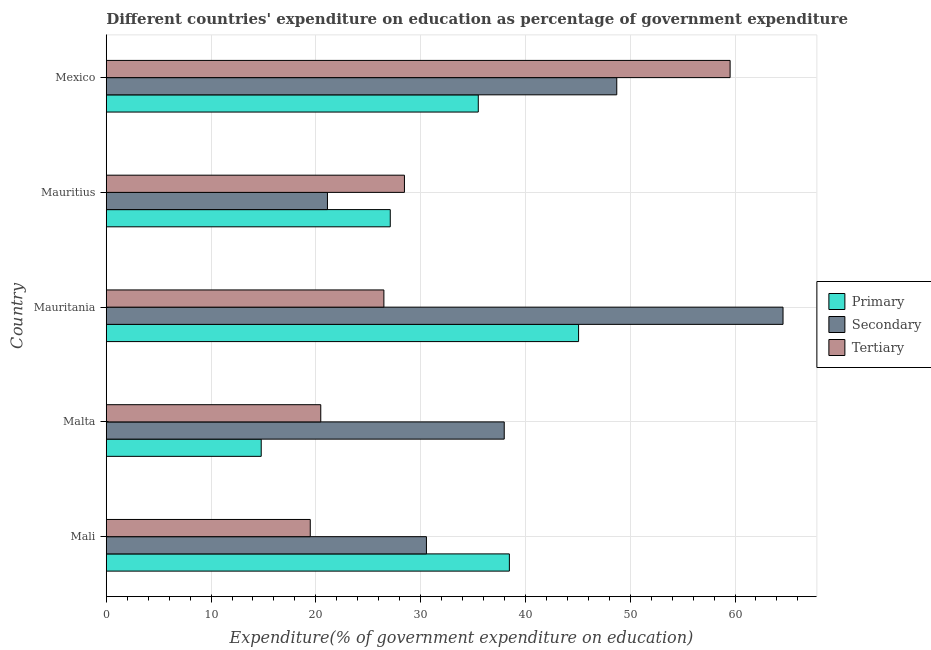How many different coloured bars are there?
Provide a short and direct response. 3. How many groups of bars are there?
Give a very brief answer. 5. Are the number of bars on each tick of the Y-axis equal?
Provide a succinct answer. Yes. How many bars are there on the 1st tick from the top?
Offer a terse response. 3. What is the label of the 4th group of bars from the top?
Give a very brief answer. Malta. In how many cases, is the number of bars for a given country not equal to the number of legend labels?
Your response must be concise. 0. What is the expenditure on tertiary education in Mauritania?
Ensure brevity in your answer.  26.49. Across all countries, what is the maximum expenditure on primary education?
Make the answer very short. 45.07. Across all countries, what is the minimum expenditure on secondary education?
Your answer should be compact. 21.11. In which country was the expenditure on primary education maximum?
Your response must be concise. Mauritania. In which country was the expenditure on primary education minimum?
Provide a succinct answer. Malta. What is the total expenditure on tertiary education in the graph?
Your response must be concise. 154.42. What is the difference between the expenditure on tertiary education in Mali and that in Malta?
Offer a terse response. -1. What is the difference between the expenditure on tertiary education in Mauritius and the expenditure on primary education in Mauritania?
Offer a very short reply. -16.62. What is the average expenditure on tertiary education per country?
Your response must be concise. 30.88. What is the difference between the expenditure on secondary education and expenditure on primary education in Mauritania?
Offer a very short reply. 19.51. What is the ratio of the expenditure on tertiary education in Mali to that in Mexico?
Your answer should be compact. 0.33. Is the difference between the expenditure on secondary education in Mauritania and Mauritius greater than the difference between the expenditure on primary education in Mauritania and Mauritius?
Offer a terse response. Yes. What is the difference between the highest and the second highest expenditure on primary education?
Offer a very short reply. 6.61. What is the difference between the highest and the lowest expenditure on secondary education?
Offer a terse response. 43.47. In how many countries, is the expenditure on secondary education greater than the average expenditure on secondary education taken over all countries?
Ensure brevity in your answer.  2. What does the 2nd bar from the top in Mali represents?
Your answer should be very brief. Secondary. What does the 1st bar from the bottom in Malta represents?
Ensure brevity in your answer.  Primary. Is it the case that in every country, the sum of the expenditure on primary education and expenditure on secondary education is greater than the expenditure on tertiary education?
Make the answer very short. Yes. Are all the bars in the graph horizontal?
Keep it short and to the point. Yes. How many countries are there in the graph?
Provide a succinct answer. 5. What is the difference between two consecutive major ticks on the X-axis?
Give a very brief answer. 10. Where does the legend appear in the graph?
Your answer should be compact. Center right. What is the title of the graph?
Make the answer very short. Different countries' expenditure on education as percentage of government expenditure. Does "Financial account" appear as one of the legend labels in the graph?
Provide a succinct answer. No. What is the label or title of the X-axis?
Your answer should be compact. Expenditure(% of government expenditure on education). What is the label or title of the Y-axis?
Make the answer very short. Country. What is the Expenditure(% of government expenditure on education) in Primary in Mali?
Make the answer very short. 38.47. What is the Expenditure(% of government expenditure on education) in Secondary in Mali?
Your answer should be compact. 30.55. What is the Expenditure(% of government expenditure on education) in Tertiary in Mali?
Your answer should be very brief. 19.47. What is the Expenditure(% of government expenditure on education) in Primary in Malta?
Ensure brevity in your answer.  14.79. What is the Expenditure(% of government expenditure on education) of Secondary in Malta?
Provide a short and direct response. 37.98. What is the Expenditure(% of government expenditure on education) of Tertiary in Malta?
Ensure brevity in your answer.  20.47. What is the Expenditure(% of government expenditure on education) in Primary in Mauritania?
Your response must be concise. 45.07. What is the Expenditure(% of government expenditure on education) in Secondary in Mauritania?
Your response must be concise. 64.58. What is the Expenditure(% of government expenditure on education) in Tertiary in Mauritania?
Provide a succinct answer. 26.49. What is the Expenditure(% of government expenditure on education) of Primary in Mauritius?
Offer a very short reply. 27.1. What is the Expenditure(% of government expenditure on education) of Secondary in Mauritius?
Provide a succinct answer. 21.11. What is the Expenditure(% of government expenditure on education) of Tertiary in Mauritius?
Give a very brief answer. 28.45. What is the Expenditure(% of government expenditure on education) of Primary in Mexico?
Keep it short and to the point. 35.5. What is the Expenditure(% of government expenditure on education) of Secondary in Mexico?
Give a very brief answer. 48.72. What is the Expenditure(% of government expenditure on education) of Tertiary in Mexico?
Give a very brief answer. 59.53. Across all countries, what is the maximum Expenditure(% of government expenditure on education) in Primary?
Your answer should be very brief. 45.07. Across all countries, what is the maximum Expenditure(% of government expenditure on education) in Secondary?
Your response must be concise. 64.58. Across all countries, what is the maximum Expenditure(% of government expenditure on education) of Tertiary?
Provide a succinct answer. 59.53. Across all countries, what is the minimum Expenditure(% of government expenditure on education) in Primary?
Provide a short and direct response. 14.79. Across all countries, what is the minimum Expenditure(% of government expenditure on education) of Secondary?
Offer a terse response. 21.11. Across all countries, what is the minimum Expenditure(% of government expenditure on education) of Tertiary?
Give a very brief answer. 19.47. What is the total Expenditure(% of government expenditure on education) in Primary in the graph?
Provide a short and direct response. 160.94. What is the total Expenditure(% of government expenditure on education) of Secondary in the graph?
Make the answer very short. 202.94. What is the total Expenditure(% of government expenditure on education) of Tertiary in the graph?
Offer a terse response. 154.42. What is the difference between the Expenditure(% of government expenditure on education) in Primary in Mali and that in Malta?
Give a very brief answer. 23.68. What is the difference between the Expenditure(% of government expenditure on education) of Secondary in Mali and that in Malta?
Keep it short and to the point. -7.42. What is the difference between the Expenditure(% of government expenditure on education) in Tertiary in Mali and that in Malta?
Provide a short and direct response. -1. What is the difference between the Expenditure(% of government expenditure on education) of Primary in Mali and that in Mauritania?
Keep it short and to the point. -6.6. What is the difference between the Expenditure(% of government expenditure on education) in Secondary in Mali and that in Mauritania?
Offer a very short reply. -34.03. What is the difference between the Expenditure(% of government expenditure on education) of Tertiary in Mali and that in Mauritania?
Your answer should be compact. -7.03. What is the difference between the Expenditure(% of government expenditure on education) of Primary in Mali and that in Mauritius?
Make the answer very short. 11.37. What is the difference between the Expenditure(% of government expenditure on education) in Secondary in Mali and that in Mauritius?
Your answer should be very brief. 9.45. What is the difference between the Expenditure(% of government expenditure on education) in Tertiary in Mali and that in Mauritius?
Give a very brief answer. -8.99. What is the difference between the Expenditure(% of government expenditure on education) of Primary in Mali and that in Mexico?
Provide a succinct answer. 2.97. What is the difference between the Expenditure(% of government expenditure on education) in Secondary in Mali and that in Mexico?
Your answer should be compact. -18.16. What is the difference between the Expenditure(% of government expenditure on education) in Tertiary in Mali and that in Mexico?
Offer a terse response. -40.06. What is the difference between the Expenditure(% of government expenditure on education) of Primary in Malta and that in Mauritania?
Offer a very short reply. -30.29. What is the difference between the Expenditure(% of government expenditure on education) in Secondary in Malta and that in Mauritania?
Your response must be concise. -26.6. What is the difference between the Expenditure(% of government expenditure on education) in Tertiary in Malta and that in Mauritania?
Ensure brevity in your answer.  -6.02. What is the difference between the Expenditure(% of government expenditure on education) in Primary in Malta and that in Mauritius?
Your answer should be compact. -12.32. What is the difference between the Expenditure(% of government expenditure on education) of Secondary in Malta and that in Mauritius?
Give a very brief answer. 16.87. What is the difference between the Expenditure(% of government expenditure on education) of Tertiary in Malta and that in Mauritius?
Provide a short and direct response. -7.98. What is the difference between the Expenditure(% of government expenditure on education) of Primary in Malta and that in Mexico?
Your answer should be very brief. -20.71. What is the difference between the Expenditure(% of government expenditure on education) of Secondary in Malta and that in Mexico?
Give a very brief answer. -10.74. What is the difference between the Expenditure(% of government expenditure on education) of Tertiary in Malta and that in Mexico?
Provide a short and direct response. -39.06. What is the difference between the Expenditure(% of government expenditure on education) in Primary in Mauritania and that in Mauritius?
Ensure brevity in your answer.  17.97. What is the difference between the Expenditure(% of government expenditure on education) in Secondary in Mauritania and that in Mauritius?
Offer a very short reply. 43.47. What is the difference between the Expenditure(% of government expenditure on education) of Tertiary in Mauritania and that in Mauritius?
Your answer should be compact. -1.96. What is the difference between the Expenditure(% of government expenditure on education) in Primary in Mauritania and that in Mexico?
Offer a very short reply. 9.57. What is the difference between the Expenditure(% of government expenditure on education) in Secondary in Mauritania and that in Mexico?
Ensure brevity in your answer.  15.87. What is the difference between the Expenditure(% of government expenditure on education) in Tertiary in Mauritania and that in Mexico?
Offer a terse response. -33.04. What is the difference between the Expenditure(% of government expenditure on education) in Primary in Mauritius and that in Mexico?
Offer a very short reply. -8.4. What is the difference between the Expenditure(% of government expenditure on education) of Secondary in Mauritius and that in Mexico?
Your answer should be very brief. -27.61. What is the difference between the Expenditure(% of government expenditure on education) in Tertiary in Mauritius and that in Mexico?
Your response must be concise. -31.08. What is the difference between the Expenditure(% of government expenditure on education) in Primary in Mali and the Expenditure(% of government expenditure on education) in Secondary in Malta?
Provide a succinct answer. 0.49. What is the difference between the Expenditure(% of government expenditure on education) in Primary in Mali and the Expenditure(% of government expenditure on education) in Tertiary in Malta?
Offer a terse response. 18. What is the difference between the Expenditure(% of government expenditure on education) of Secondary in Mali and the Expenditure(% of government expenditure on education) of Tertiary in Malta?
Provide a short and direct response. 10.08. What is the difference between the Expenditure(% of government expenditure on education) in Primary in Mali and the Expenditure(% of government expenditure on education) in Secondary in Mauritania?
Keep it short and to the point. -26.11. What is the difference between the Expenditure(% of government expenditure on education) of Primary in Mali and the Expenditure(% of government expenditure on education) of Tertiary in Mauritania?
Give a very brief answer. 11.97. What is the difference between the Expenditure(% of government expenditure on education) of Secondary in Mali and the Expenditure(% of government expenditure on education) of Tertiary in Mauritania?
Your answer should be compact. 4.06. What is the difference between the Expenditure(% of government expenditure on education) in Primary in Mali and the Expenditure(% of government expenditure on education) in Secondary in Mauritius?
Ensure brevity in your answer.  17.36. What is the difference between the Expenditure(% of government expenditure on education) of Primary in Mali and the Expenditure(% of government expenditure on education) of Tertiary in Mauritius?
Provide a short and direct response. 10.01. What is the difference between the Expenditure(% of government expenditure on education) of Secondary in Mali and the Expenditure(% of government expenditure on education) of Tertiary in Mauritius?
Provide a succinct answer. 2.1. What is the difference between the Expenditure(% of government expenditure on education) of Primary in Mali and the Expenditure(% of government expenditure on education) of Secondary in Mexico?
Give a very brief answer. -10.25. What is the difference between the Expenditure(% of government expenditure on education) in Primary in Mali and the Expenditure(% of government expenditure on education) in Tertiary in Mexico?
Keep it short and to the point. -21.06. What is the difference between the Expenditure(% of government expenditure on education) of Secondary in Mali and the Expenditure(% of government expenditure on education) of Tertiary in Mexico?
Give a very brief answer. -28.98. What is the difference between the Expenditure(% of government expenditure on education) in Primary in Malta and the Expenditure(% of government expenditure on education) in Secondary in Mauritania?
Ensure brevity in your answer.  -49.8. What is the difference between the Expenditure(% of government expenditure on education) of Primary in Malta and the Expenditure(% of government expenditure on education) of Tertiary in Mauritania?
Ensure brevity in your answer.  -11.71. What is the difference between the Expenditure(% of government expenditure on education) of Secondary in Malta and the Expenditure(% of government expenditure on education) of Tertiary in Mauritania?
Your answer should be very brief. 11.48. What is the difference between the Expenditure(% of government expenditure on education) in Primary in Malta and the Expenditure(% of government expenditure on education) in Secondary in Mauritius?
Your response must be concise. -6.32. What is the difference between the Expenditure(% of government expenditure on education) of Primary in Malta and the Expenditure(% of government expenditure on education) of Tertiary in Mauritius?
Give a very brief answer. -13.67. What is the difference between the Expenditure(% of government expenditure on education) in Secondary in Malta and the Expenditure(% of government expenditure on education) in Tertiary in Mauritius?
Your response must be concise. 9.52. What is the difference between the Expenditure(% of government expenditure on education) of Primary in Malta and the Expenditure(% of government expenditure on education) of Secondary in Mexico?
Your answer should be compact. -33.93. What is the difference between the Expenditure(% of government expenditure on education) in Primary in Malta and the Expenditure(% of government expenditure on education) in Tertiary in Mexico?
Your answer should be compact. -44.74. What is the difference between the Expenditure(% of government expenditure on education) of Secondary in Malta and the Expenditure(% of government expenditure on education) of Tertiary in Mexico?
Offer a very short reply. -21.55. What is the difference between the Expenditure(% of government expenditure on education) of Primary in Mauritania and the Expenditure(% of government expenditure on education) of Secondary in Mauritius?
Provide a succinct answer. 23.96. What is the difference between the Expenditure(% of government expenditure on education) of Primary in Mauritania and the Expenditure(% of government expenditure on education) of Tertiary in Mauritius?
Your answer should be compact. 16.62. What is the difference between the Expenditure(% of government expenditure on education) in Secondary in Mauritania and the Expenditure(% of government expenditure on education) in Tertiary in Mauritius?
Provide a succinct answer. 36.13. What is the difference between the Expenditure(% of government expenditure on education) in Primary in Mauritania and the Expenditure(% of government expenditure on education) in Secondary in Mexico?
Ensure brevity in your answer.  -3.64. What is the difference between the Expenditure(% of government expenditure on education) in Primary in Mauritania and the Expenditure(% of government expenditure on education) in Tertiary in Mexico?
Give a very brief answer. -14.46. What is the difference between the Expenditure(% of government expenditure on education) of Secondary in Mauritania and the Expenditure(% of government expenditure on education) of Tertiary in Mexico?
Give a very brief answer. 5.05. What is the difference between the Expenditure(% of government expenditure on education) in Primary in Mauritius and the Expenditure(% of government expenditure on education) in Secondary in Mexico?
Ensure brevity in your answer.  -21.61. What is the difference between the Expenditure(% of government expenditure on education) of Primary in Mauritius and the Expenditure(% of government expenditure on education) of Tertiary in Mexico?
Provide a short and direct response. -32.43. What is the difference between the Expenditure(% of government expenditure on education) in Secondary in Mauritius and the Expenditure(% of government expenditure on education) in Tertiary in Mexico?
Your answer should be compact. -38.42. What is the average Expenditure(% of government expenditure on education) of Primary per country?
Your answer should be compact. 32.19. What is the average Expenditure(% of government expenditure on education) of Secondary per country?
Provide a succinct answer. 40.59. What is the average Expenditure(% of government expenditure on education) of Tertiary per country?
Your response must be concise. 30.88. What is the difference between the Expenditure(% of government expenditure on education) of Primary and Expenditure(% of government expenditure on education) of Secondary in Mali?
Your answer should be very brief. 7.91. What is the difference between the Expenditure(% of government expenditure on education) of Primary and Expenditure(% of government expenditure on education) of Tertiary in Mali?
Your answer should be compact. 19. What is the difference between the Expenditure(% of government expenditure on education) in Secondary and Expenditure(% of government expenditure on education) in Tertiary in Mali?
Give a very brief answer. 11.09. What is the difference between the Expenditure(% of government expenditure on education) of Primary and Expenditure(% of government expenditure on education) of Secondary in Malta?
Give a very brief answer. -23.19. What is the difference between the Expenditure(% of government expenditure on education) in Primary and Expenditure(% of government expenditure on education) in Tertiary in Malta?
Provide a short and direct response. -5.68. What is the difference between the Expenditure(% of government expenditure on education) in Secondary and Expenditure(% of government expenditure on education) in Tertiary in Malta?
Your answer should be very brief. 17.51. What is the difference between the Expenditure(% of government expenditure on education) of Primary and Expenditure(% of government expenditure on education) of Secondary in Mauritania?
Provide a succinct answer. -19.51. What is the difference between the Expenditure(% of government expenditure on education) of Primary and Expenditure(% of government expenditure on education) of Tertiary in Mauritania?
Provide a succinct answer. 18.58. What is the difference between the Expenditure(% of government expenditure on education) of Secondary and Expenditure(% of government expenditure on education) of Tertiary in Mauritania?
Your response must be concise. 38.09. What is the difference between the Expenditure(% of government expenditure on education) in Primary and Expenditure(% of government expenditure on education) in Secondary in Mauritius?
Offer a terse response. 5.99. What is the difference between the Expenditure(% of government expenditure on education) of Primary and Expenditure(% of government expenditure on education) of Tertiary in Mauritius?
Ensure brevity in your answer.  -1.35. What is the difference between the Expenditure(% of government expenditure on education) of Secondary and Expenditure(% of government expenditure on education) of Tertiary in Mauritius?
Your answer should be compact. -7.35. What is the difference between the Expenditure(% of government expenditure on education) of Primary and Expenditure(% of government expenditure on education) of Secondary in Mexico?
Ensure brevity in your answer.  -13.21. What is the difference between the Expenditure(% of government expenditure on education) of Primary and Expenditure(% of government expenditure on education) of Tertiary in Mexico?
Your answer should be compact. -24.03. What is the difference between the Expenditure(% of government expenditure on education) in Secondary and Expenditure(% of government expenditure on education) in Tertiary in Mexico?
Make the answer very short. -10.82. What is the ratio of the Expenditure(% of government expenditure on education) of Primary in Mali to that in Malta?
Your answer should be very brief. 2.6. What is the ratio of the Expenditure(% of government expenditure on education) of Secondary in Mali to that in Malta?
Keep it short and to the point. 0.8. What is the ratio of the Expenditure(% of government expenditure on education) of Tertiary in Mali to that in Malta?
Offer a terse response. 0.95. What is the ratio of the Expenditure(% of government expenditure on education) in Primary in Mali to that in Mauritania?
Ensure brevity in your answer.  0.85. What is the ratio of the Expenditure(% of government expenditure on education) in Secondary in Mali to that in Mauritania?
Provide a short and direct response. 0.47. What is the ratio of the Expenditure(% of government expenditure on education) of Tertiary in Mali to that in Mauritania?
Your answer should be very brief. 0.73. What is the ratio of the Expenditure(% of government expenditure on education) of Primary in Mali to that in Mauritius?
Your answer should be compact. 1.42. What is the ratio of the Expenditure(% of government expenditure on education) of Secondary in Mali to that in Mauritius?
Offer a very short reply. 1.45. What is the ratio of the Expenditure(% of government expenditure on education) of Tertiary in Mali to that in Mauritius?
Provide a short and direct response. 0.68. What is the ratio of the Expenditure(% of government expenditure on education) of Primary in Mali to that in Mexico?
Your answer should be compact. 1.08. What is the ratio of the Expenditure(% of government expenditure on education) in Secondary in Mali to that in Mexico?
Make the answer very short. 0.63. What is the ratio of the Expenditure(% of government expenditure on education) of Tertiary in Mali to that in Mexico?
Ensure brevity in your answer.  0.33. What is the ratio of the Expenditure(% of government expenditure on education) in Primary in Malta to that in Mauritania?
Your response must be concise. 0.33. What is the ratio of the Expenditure(% of government expenditure on education) of Secondary in Malta to that in Mauritania?
Your answer should be very brief. 0.59. What is the ratio of the Expenditure(% of government expenditure on education) of Tertiary in Malta to that in Mauritania?
Provide a succinct answer. 0.77. What is the ratio of the Expenditure(% of government expenditure on education) of Primary in Malta to that in Mauritius?
Your response must be concise. 0.55. What is the ratio of the Expenditure(% of government expenditure on education) in Secondary in Malta to that in Mauritius?
Make the answer very short. 1.8. What is the ratio of the Expenditure(% of government expenditure on education) of Tertiary in Malta to that in Mauritius?
Make the answer very short. 0.72. What is the ratio of the Expenditure(% of government expenditure on education) in Primary in Malta to that in Mexico?
Provide a short and direct response. 0.42. What is the ratio of the Expenditure(% of government expenditure on education) in Secondary in Malta to that in Mexico?
Provide a succinct answer. 0.78. What is the ratio of the Expenditure(% of government expenditure on education) of Tertiary in Malta to that in Mexico?
Make the answer very short. 0.34. What is the ratio of the Expenditure(% of government expenditure on education) of Primary in Mauritania to that in Mauritius?
Your answer should be very brief. 1.66. What is the ratio of the Expenditure(% of government expenditure on education) in Secondary in Mauritania to that in Mauritius?
Your response must be concise. 3.06. What is the ratio of the Expenditure(% of government expenditure on education) of Tertiary in Mauritania to that in Mauritius?
Your response must be concise. 0.93. What is the ratio of the Expenditure(% of government expenditure on education) in Primary in Mauritania to that in Mexico?
Offer a very short reply. 1.27. What is the ratio of the Expenditure(% of government expenditure on education) in Secondary in Mauritania to that in Mexico?
Give a very brief answer. 1.33. What is the ratio of the Expenditure(% of government expenditure on education) of Tertiary in Mauritania to that in Mexico?
Give a very brief answer. 0.45. What is the ratio of the Expenditure(% of government expenditure on education) of Primary in Mauritius to that in Mexico?
Ensure brevity in your answer.  0.76. What is the ratio of the Expenditure(% of government expenditure on education) in Secondary in Mauritius to that in Mexico?
Your response must be concise. 0.43. What is the ratio of the Expenditure(% of government expenditure on education) in Tertiary in Mauritius to that in Mexico?
Ensure brevity in your answer.  0.48. What is the difference between the highest and the second highest Expenditure(% of government expenditure on education) of Primary?
Provide a short and direct response. 6.6. What is the difference between the highest and the second highest Expenditure(% of government expenditure on education) in Secondary?
Your answer should be very brief. 15.87. What is the difference between the highest and the second highest Expenditure(% of government expenditure on education) of Tertiary?
Provide a short and direct response. 31.08. What is the difference between the highest and the lowest Expenditure(% of government expenditure on education) in Primary?
Offer a terse response. 30.29. What is the difference between the highest and the lowest Expenditure(% of government expenditure on education) in Secondary?
Your response must be concise. 43.47. What is the difference between the highest and the lowest Expenditure(% of government expenditure on education) of Tertiary?
Give a very brief answer. 40.06. 